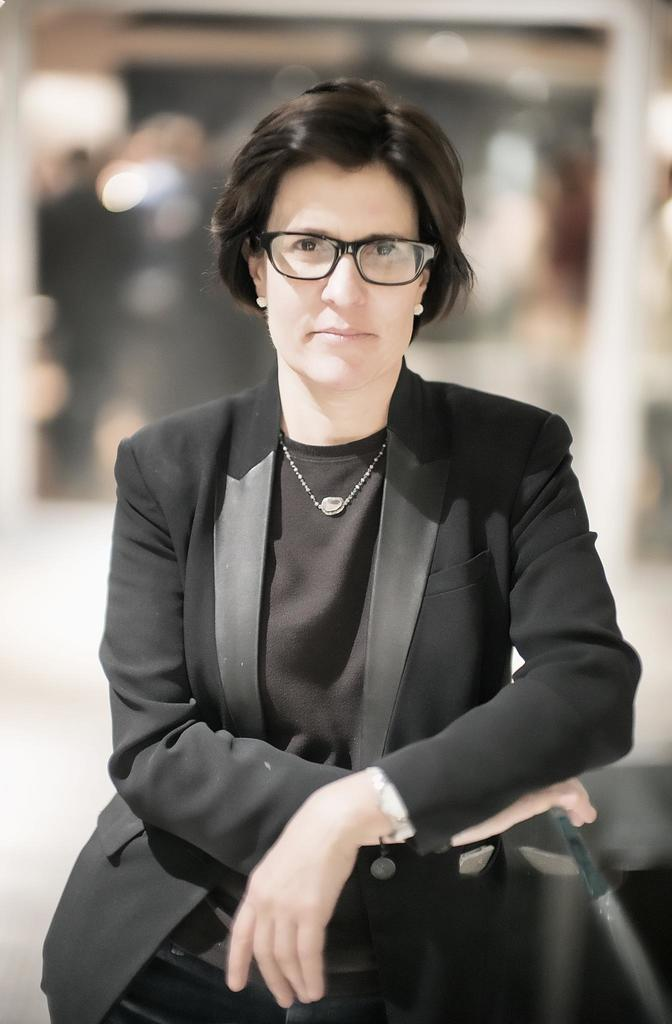Who is the main subject in the image? There is a woman in the image. What is the woman doing in the image? The woman is standing and posing for a photo. What is the woman wearing in the image? The woman is wearing a black dress. How is the background of the woman depicted in the image? The background of the woman is blurred. What book is the woman holding in the image? There is no book present in the image; the woman is posing for a photo while wearing a black dress. 